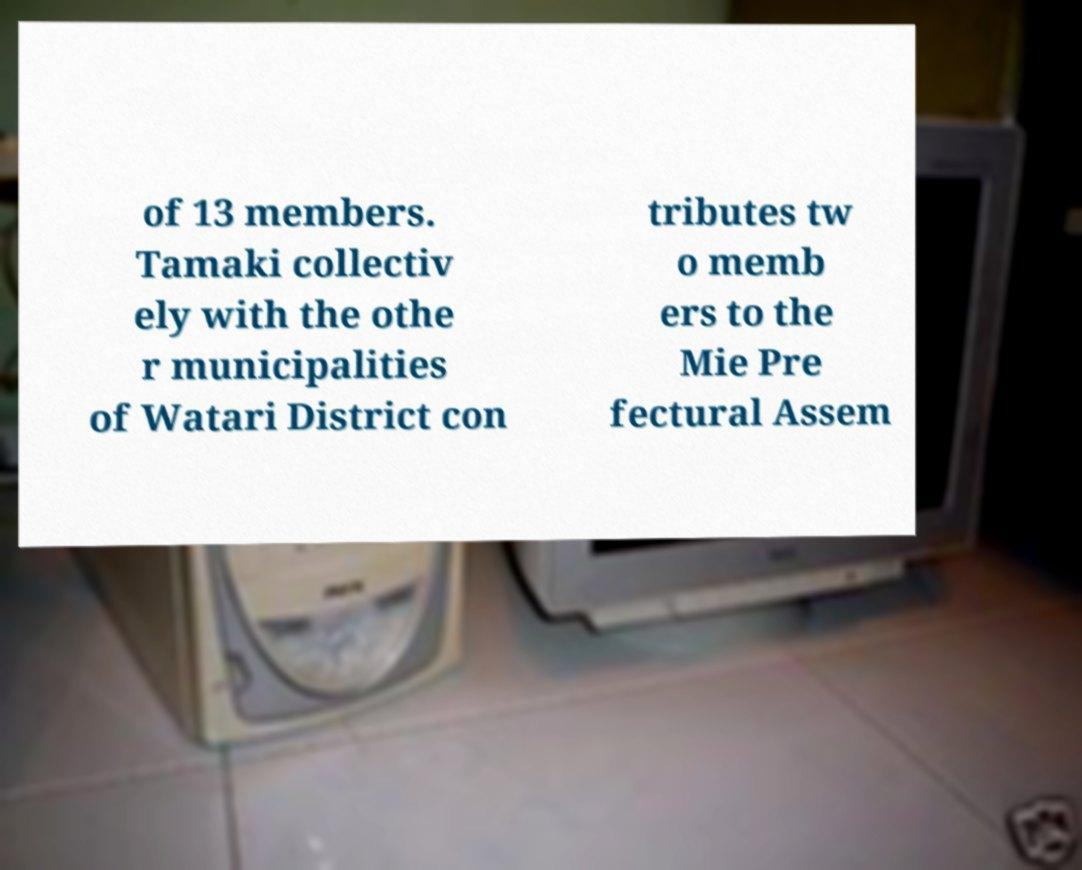I need the written content from this picture converted into text. Can you do that? of 13 members. Tamaki collectiv ely with the othe r municipalities of Watari District con tributes tw o memb ers to the Mie Pre fectural Assem 